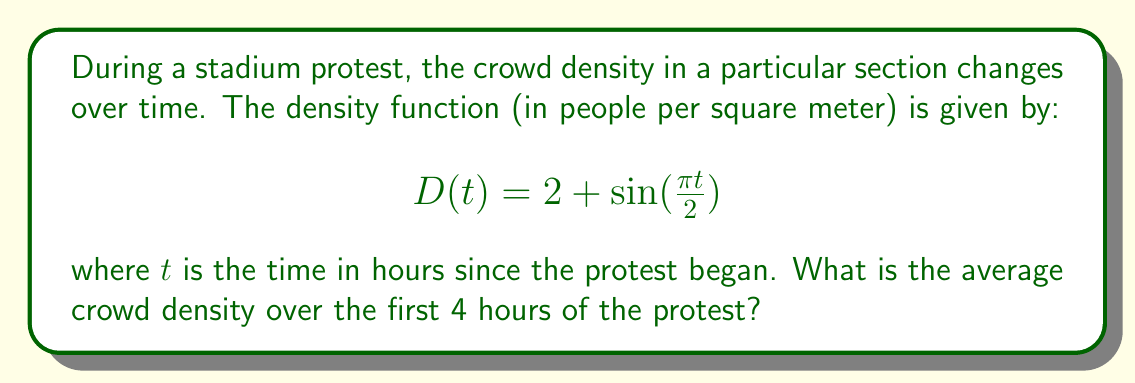Provide a solution to this math problem. To find the average crowd density over a time interval, we need to calculate the definite integral of the density function over that interval and divide by the length of the interval. This is equivalent to finding the average value of the function.

1) The average value of a function $f(x)$ over an interval $[a,b]$ is given by:

   $$\frac{1}{b-a} \int_{a}^{b} f(x) dx$$

2) In our case, $f(t) = D(t) = 2 + \sin(\frac{\pi t}{2})$, $a = 0$, and $b = 4$.

3) Let's set up the integral:

   $$\text{Average Density} = \frac{1}{4-0} \int_{0}^{4} (2 + \sin(\frac{\pi t}{2})) dt$$

4) Simplify:

   $$\text{Average Density} = \frac{1}{4} \int_{0}^{4} (2 + \sin(\frac{\pi t}{2})) dt$$

5) Integrate:

   $$\frac{1}{4} \left[2t - \frac{2}{\pi}\cos(\frac{\pi t}{2})\right]_{0}^{4}$$

6) Evaluate the integral:

   $$\frac{1}{4} \left[(8 - \frac{2}{\pi}\cos(2\pi)) - (0 - \frac{2}{\pi}\cos(0))\right]$$

7) Simplify:

   $$\frac{1}{4} \left[8 - \frac{2}{\pi}\cos(2\pi) + \frac{2}{\pi}\right]$$

8) Note that $\cos(2\pi) = 1$, so:

   $$\frac{1}{4} \left[8 - \frac{2}{\pi} + \frac{2}{\pi}\right] = \frac{8}{4} = 2$$

Therefore, the average crowd density over the first 4 hours of the protest is 2 people per square meter.
Answer: 2 people per square meter 